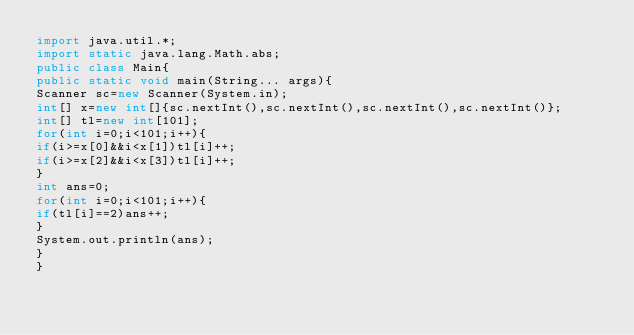<code> <loc_0><loc_0><loc_500><loc_500><_Java_>import java.util.*;
import static java.lang.Math.abs;
public class Main{
public static void main(String... args){
Scanner sc=new Scanner(System.in);
int[] x=new int[]{sc.nextInt(),sc.nextInt(),sc.nextInt(),sc.nextInt()};
int[] tl=new int[101];
for(int i=0;i<101;i++){
if(i>=x[0]&&i<x[1])tl[i]++;
if(i>=x[2]&&i<x[3])tl[i]++;
}
int ans=0;
for(int i=0;i<101;i++){
if(tl[i]==2)ans++;
}
System.out.println(ans);
}
}
</code> 